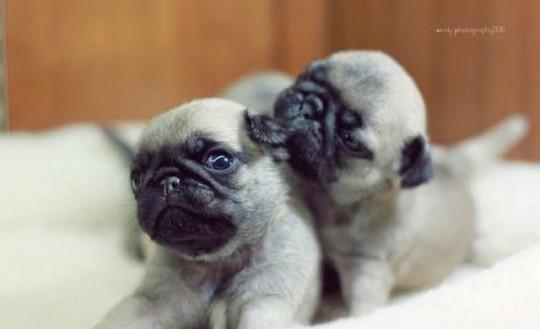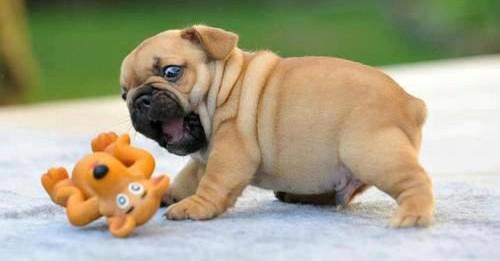The first image is the image on the left, the second image is the image on the right. Evaluate the accuracy of this statement regarding the images: "There are exactly 3 dogs depicted.". Is it true? Answer yes or no. Yes. 